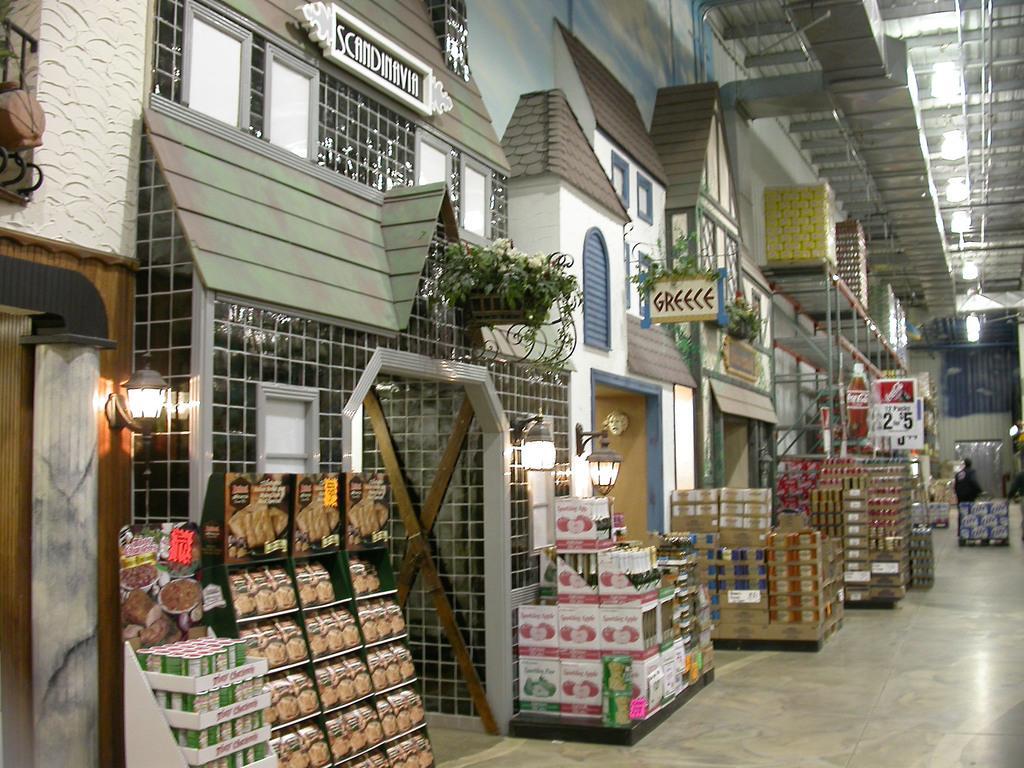Please provide a concise description of this image. Here I can see many boxes placed on the floor. In the middle of the image there is a building and I can see few windows. On the right side there is a person facing towards the back side. At the back of this person there is a box placed on the floor. In the top right-hand corner there are few lights attached to a metal rod. 